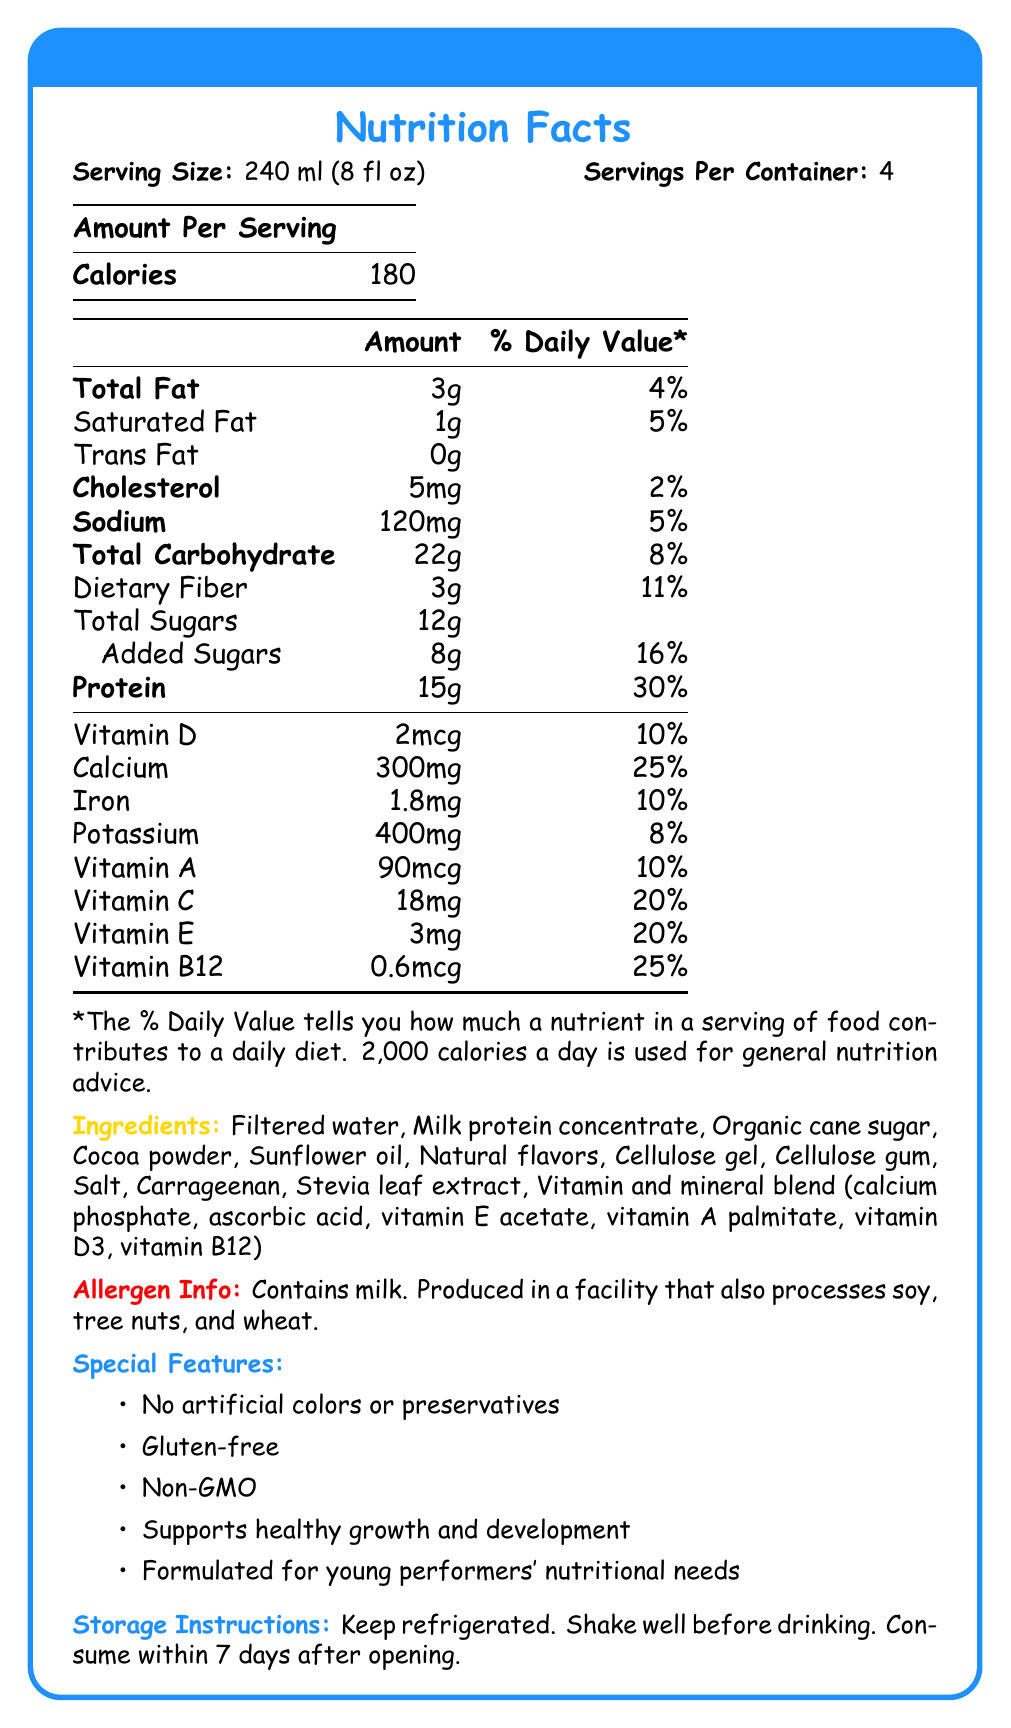What is the serving size of the StudioStar Protein Shake? The serving size is listed at the top of the Nutrition Facts label under Serving Size.
Answer: 240 ml (8 fl oz) How many servings are there per container? This information is found at the top of the Nutrition Facts label under Servings Per Container.
Answer: 4 How many calories are in one serving of the StudioStar Protein Shake? The amount of calories per serving is listed prominently under Amount Per Serving.
Answer: 180 What is the daily value percentage of protein per serving? Next to the protein amount (15g) on the Nutrition Facts label, the daily value percentage is listed as 30%.
Answer: 30% What are the special features of the StudioStar Protein Shake? The special features are detailed at the bottom section of the document.
Answer: No artificial colors or preservatives, Gluten-free, Non-GMO, Supports healthy growth and development, Formulated for young performers' nutritional needs How much dietary fiber is in one serving of the StudioStar Protein Shake? Next to Total Carbohydrate on the Nutrition Facts label, dietary fiber is listed as 3g.
Answer: 3g How much calcium is in one serving? The amount of calcium is listed under the vitamins and minerals section of the Nutrition Facts label.
Answer: 300mg What should you do before drinking the StudioStar Protein Shake? A. Freeze it B. Shake it well C. Mix it with water D. Cook it The storage instructions section advises to "Shake well before drinking."
Answer: B Which allergen is explicitly mentioned in the document? A. Soy B. Tree nuts C. Milk D. Wheat The allergen information specifically mentions that the product contains milk.
Answer: C Is the StudioStar Protein Shake gluten-free? The document states in the special features section that it is gluten-free.
Answer: Yes Summarize the main idea of the Nutrition Facts label for StudioStar Protein Shake. The document is designed to give a comprehensive overview of the nutritional content and special attributes, catering specifically to the dietary needs of young performers.
Answer: The label provides detailed nutritional information and important details about the StudioStar Protein Shake, a child-friendly protein drink designed for young actors. It includes serving size, calories, macronutrients, vitamins, minerals, ingredients, allergen information, special features, and storage instructions. When should you consume the shake after opening it? The storage instructions specify to consume the shake within 7 days after opening.
Answer: Within 7 days How much sodium is in one serving of the shake? The amount of sodium per serving is listed on the Nutrition Facts label.
Answer: 120mg How much vitamin B12 does one serving provide? The amount of vitamin B12 is listed under the vitamins and minerals section of the Nutrition Facts label.
Answer: 0.6mcg What is one ingredient not listed in the document? The document provides a detailed ingredients list; any ingredient not listed cannot be determined from the document.
Answer: Cannot be determined 